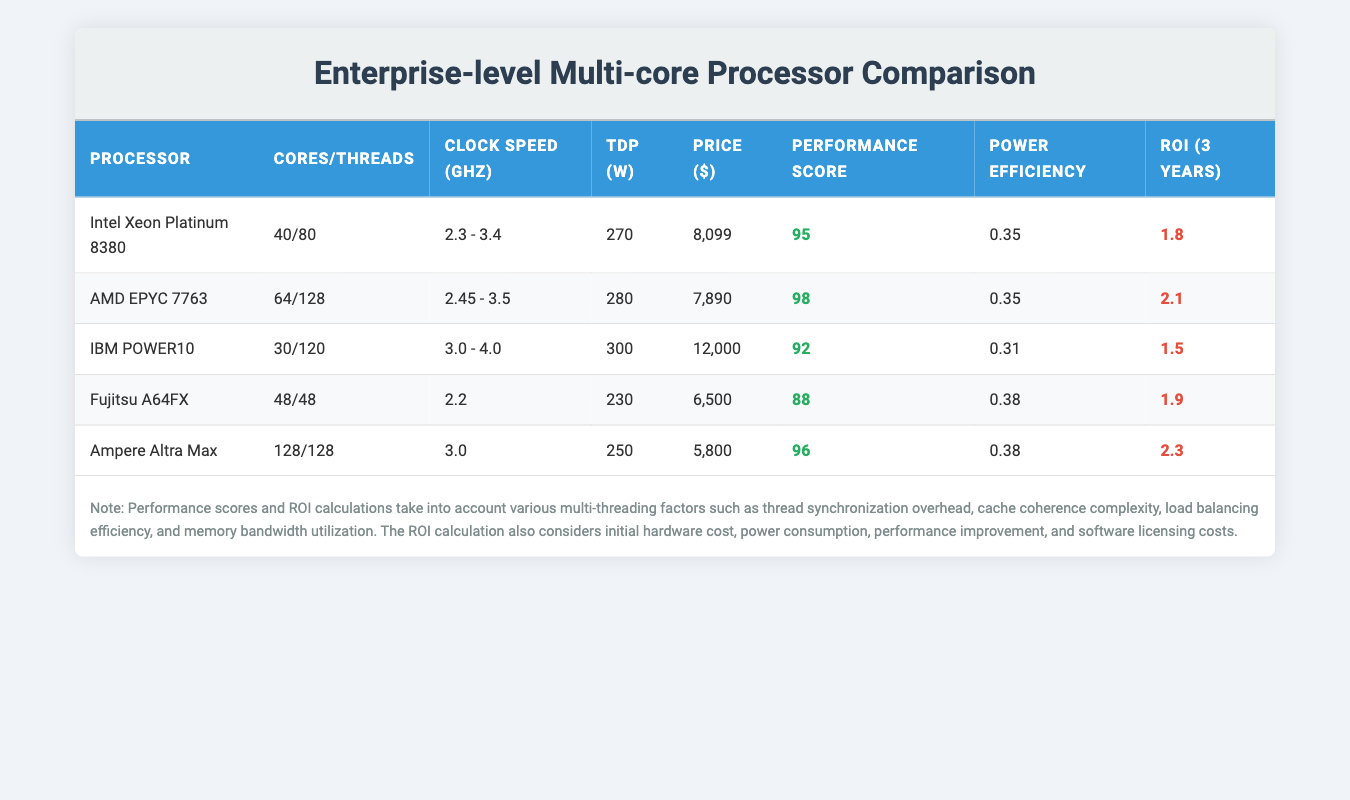What is the price of the Intel Xeon Platinum 8380? The table lists the Intel Xeon Platinum 8380 with a price of $8099. The price is explicitly mentioned in the corresponding row.
Answer: 8099 Which processor has the highest number of cores? Upon reviewing the "Cores/Threads" column, the Ampere Altra Max has 128 cores, which is the highest among all the processors listed.
Answer: Ampere Altra Max What is the ROI for the AMD EPYC 7763? The ROI for the AMD EPYC 7763 is specified in the "ROI (3 years)" column as 2.1, which can be directly referenced from the table.
Answer: 2.1 What is the average performance score of the listed processors? To find the average performance score, sum the performance scores of all processors (95 + 98 + 92 + 88 + 96 = 469) and divide by 5 (since there are five processors), resulting in an average of 93.8.
Answer: 93.8 Is the power efficiency of the IBM POWER10 lower than that of the Ampere Altra Max? Comparing the "Power Efficiency" values reveals that IBM POWER10 has a power efficiency of 0.31, while Ampere Altra Max has 0.38. Since 0.31 < 0.38, the answer is yes.
Answer: Yes Which processor offers the best return on investment based on the ROI value? Among the listed processors, the Ampere Altra Max has the highest ROI of 2.3, making it the best option for return on investment. This is identified by comparing the "ROI (3 years)" column values across all processors.
Answer: Ampere Altra Max What is the total TDP (Thermal Design Power) for all processors? By adding the TDP values together (270 + 280 + 300 + 230 + 250 = 1330), we find that the total TDP for all processors is 1330 watts. This is calculated by summing the individual TDPs.
Answer: 1330 Does the Fujitsu A64FX processor have a performance score higher than 90? The performance score for Fujitsu A64FX is 88, which is below 90. Therefore, the answer is no.
Answer: No Which processor has the lowest price? By comparing prices listed in the "Price ($)" column, the Fujitsu A64FX at $6500 is the lowest price among all processors. This conclusion is drawn from scanning the prices in the table.
Answer: Fujitsu A64FX 